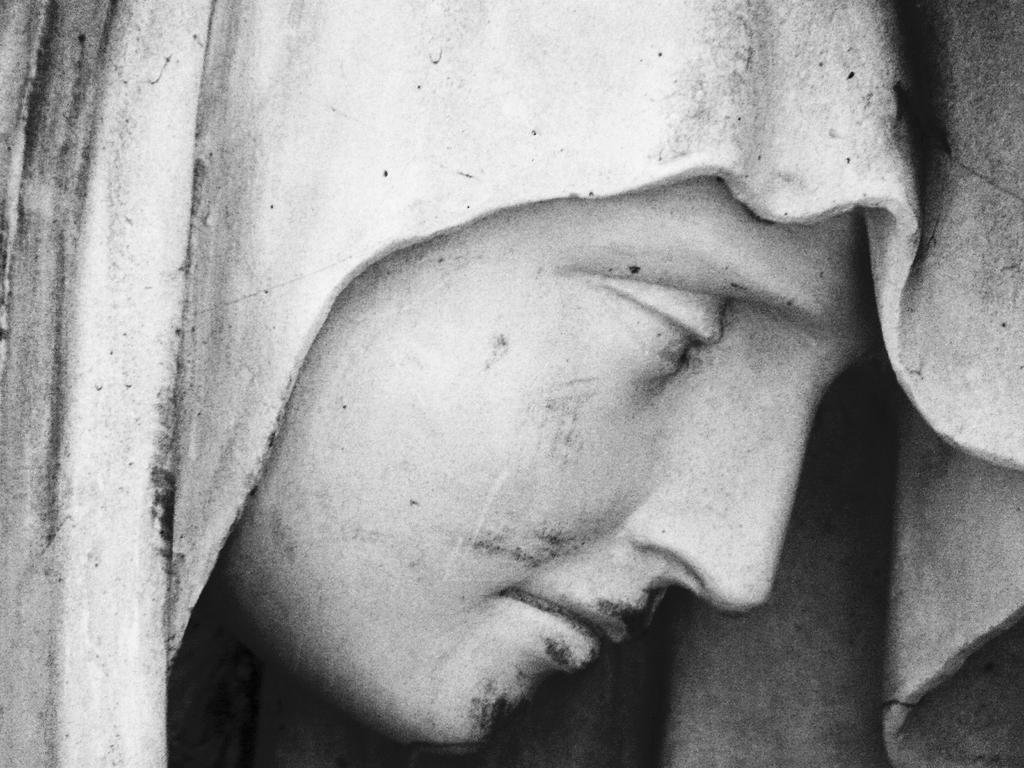What is the main subject of the image? The main subject of the image is a sculpture. Can you describe the sculpture in more detail? The sculpture is of a person's face. Where can you buy a fictional yam in the image? There is no store or yam present in the image, so it is not possible to answer that question. 